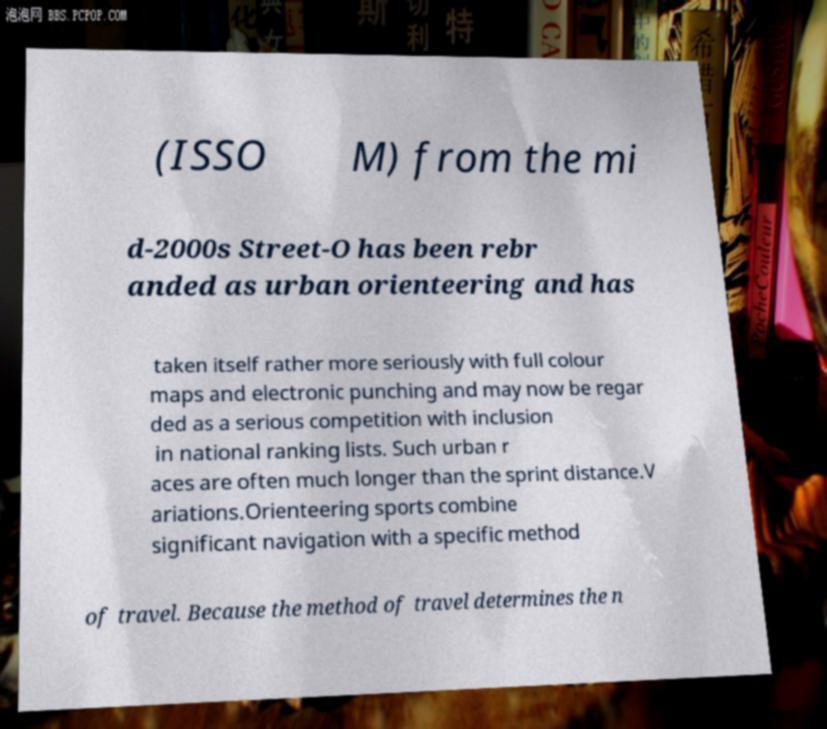Please identify and transcribe the text found in this image. (ISSO M) from the mi d-2000s Street-O has been rebr anded as urban orienteering and has taken itself rather more seriously with full colour maps and electronic punching and may now be regar ded as a serious competition with inclusion in national ranking lists. Such urban r aces are often much longer than the sprint distance.V ariations.Orienteering sports combine significant navigation with a specific method of travel. Because the method of travel determines the n 